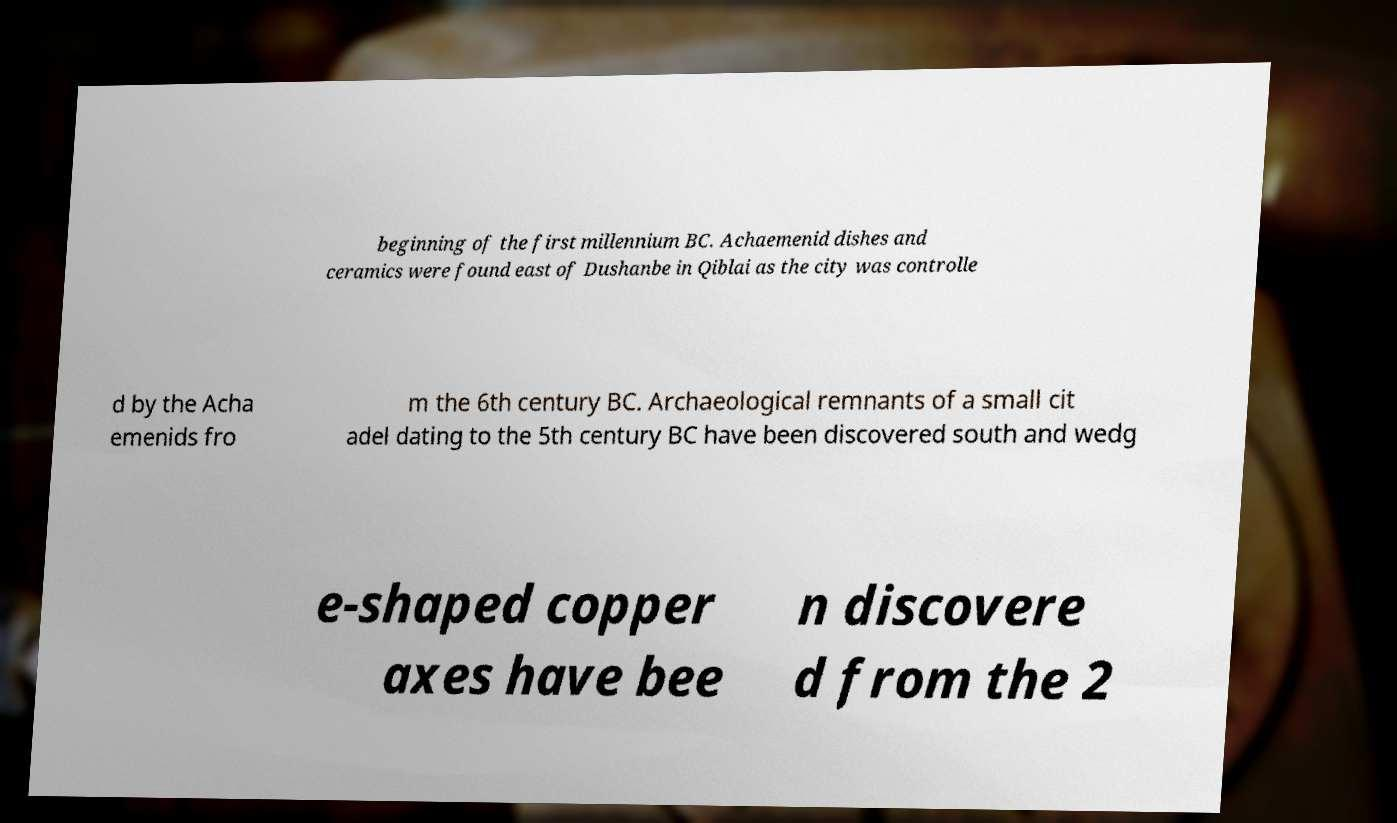Please identify and transcribe the text found in this image. beginning of the first millennium BC. Achaemenid dishes and ceramics were found east of Dushanbe in Qiblai as the city was controlle d by the Acha emenids fro m the 6th century BC. Archaeological remnants of a small cit adel dating to the 5th century BC have been discovered south and wedg e-shaped copper axes have bee n discovere d from the 2 